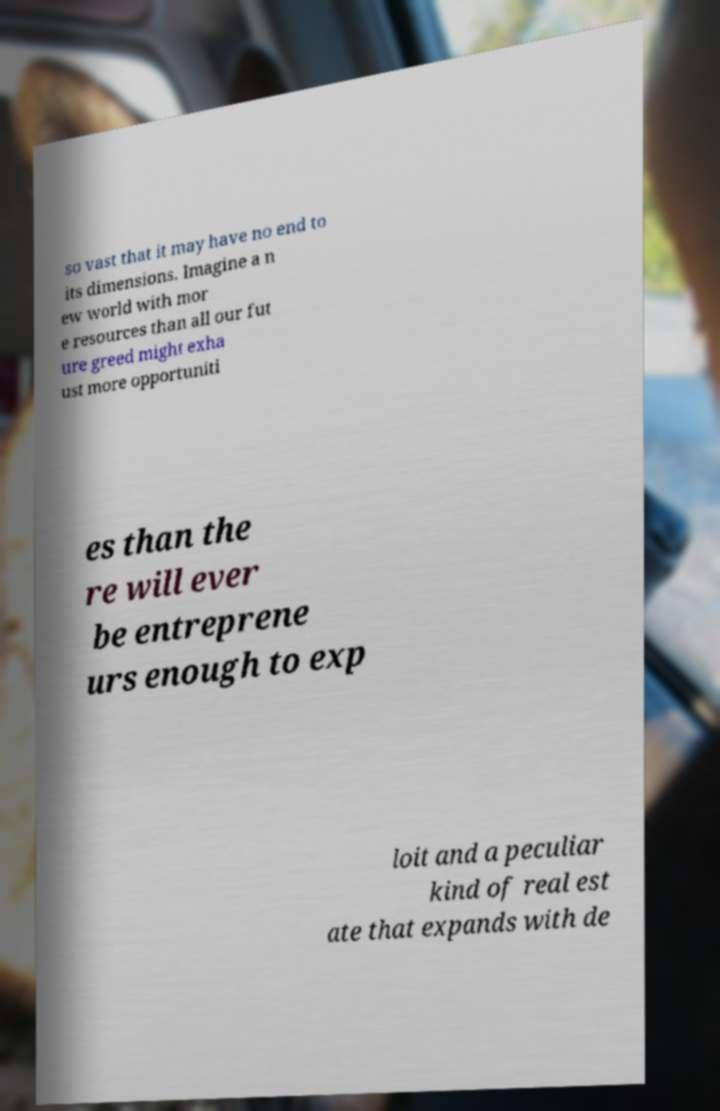Please identify and transcribe the text found in this image. so vast that it may have no end to its dimensions. Imagine a n ew world with mor e resources than all our fut ure greed might exha ust more opportuniti es than the re will ever be entreprene urs enough to exp loit and a peculiar kind of real est ate that expands with de 